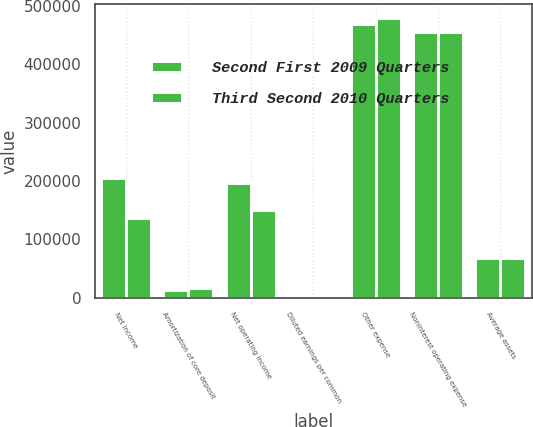Convert chart. <chart><loc_0><loc_0><loc_500><loc_500><stacked_bar_chart><ecel><fcel>Net income<fcel>Amortization of core deposit<fcel>Net operating income<fcel>Diluted earnings per common<fcel>Other expense<fcel>Noninterest operating expense<fcel>Average assets<nl><fcel>Second First 2009 Quarters<fcel>204442<fcel>13269<fcel>196235<fcel>1.59<fcel>469274<fcel>455234<fcel>68502<nl><fcel>Third Second 2010 Quarters<fcel>136818<fcel>16730<fcel>150776<fcel>1.04<fcel>478451<fcel>455457<fcel>68919<nl></chart> 